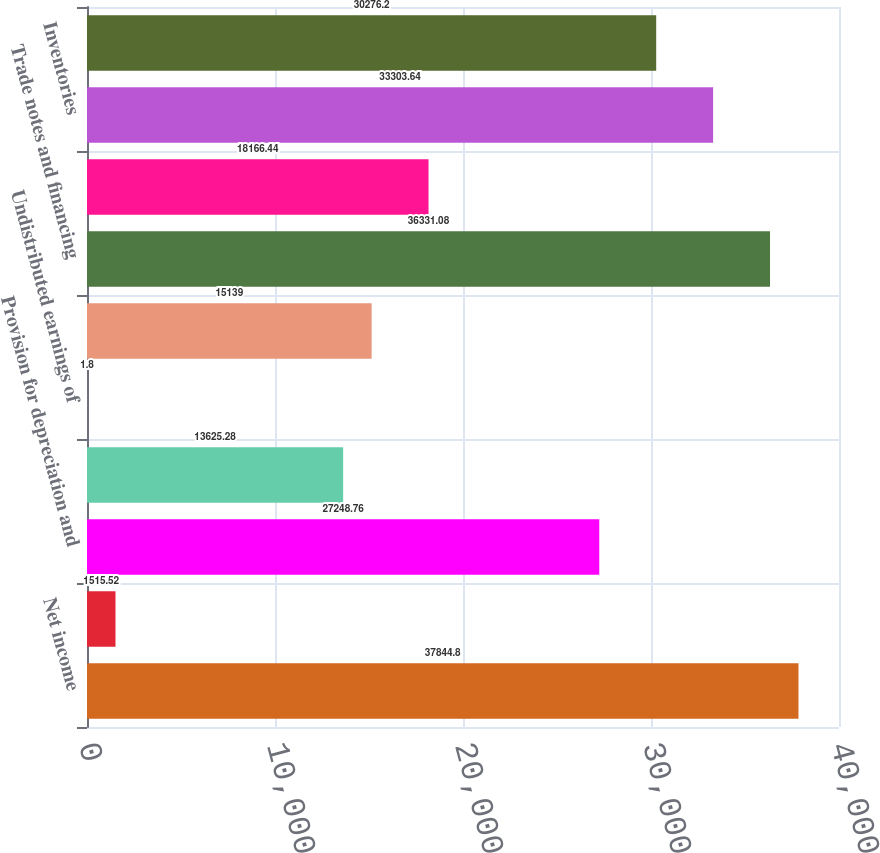Convert chart. <chart><loc_0><loc_0><loc_500><loc_500><bar_chart><fcel>Net income<fcel>Provision for credit losses<fcel>Provision for depreciation and<fcel>Share-based compensation<fcel>Undistributed earnings of<fcel>Credit for deferred income<fcel>Trade notes and financing<fcel>Insurance receivables<fcel>Inventories<fcel>Accounts payable and accrued<nl><fcel>37844.8<fcel>1515.52<fcel>27248.8<fcel>13625.3<fcel>1.8<fcel>15139<fcel>36331.1<fcel>18166.4<fcel>33303.6<fcel>30276.2<nl></chart> 